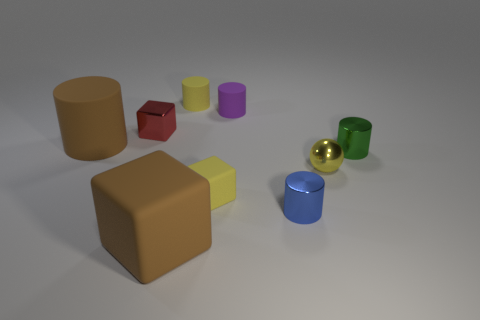Subtract 1 cylinders. How many cylinders are left? 4 Subtract all green cylinders. How many cylinders are left? 4 Subtract all green metal cylinders. How many cylinders are left? 4 Subtract all gray cylinders. Subtract all cyan balls. How many cylinders are left? 5 Subtract all cylinders. How many objects are left? 4 Add 1 cyan metallic cubes. How many cyan metallic cubes exist? 1 Subtract 1 red blocks. How many objects are left? 8 Subtract all tiny cubes. Subtract all big brown matte things. How many objects are left? 5 Add 6 big cubes. How many big cubes are left? 7 